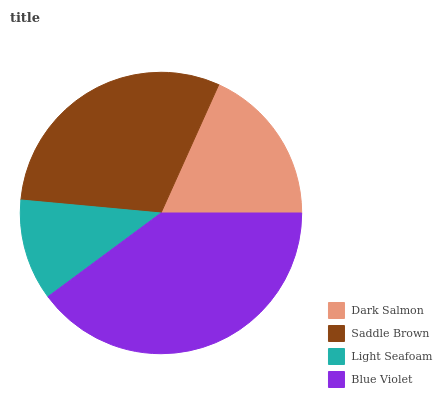Is Light Seafoam the minimum?
Answer yes or no. Yes. Is Blue Violet the maximum?
Answer yes or no. Yes. Is Saddle Brown the minimum?
Answer yes or no. No. Is Saddle Brown the maximum?
Answer yes or no. No. Is Saddle Brown greater than Dark Salmon?
Answer yes or no. Yes. Is Dark Salmon less than Saddle Brown?
Answer yes or no. Yes. Is Dark Salmon greater than Saddle Brown?
Answer yes or no. No. Is Saddle Brown less than Dark Salmon?
Answer yes or no. No. Is Saddle Brown the high median?
Answer yes or no. Yes. Is Dark Salmon the low median?
Answer yes or no. Yes. Is Blue Violet the high median?
Answer yes or no. No. Is Light Seafoam the low median?
Answer yes or no. No. 